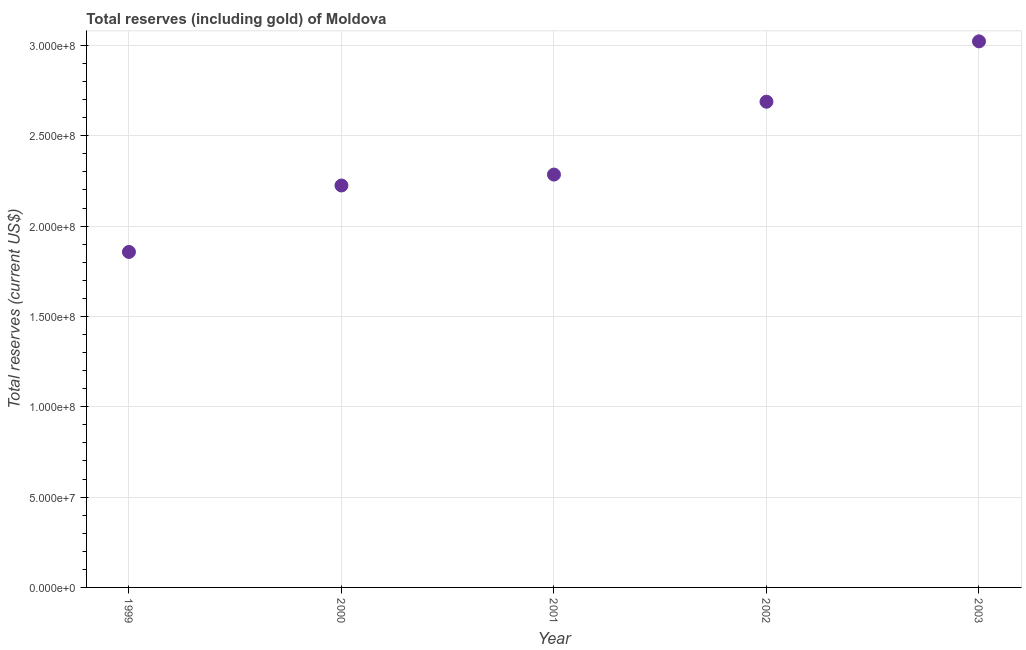What is the total reserves (including gold) in 2002?
Provide a short and direct response. 2.69e+08. Across all years, what is the maximum total reserves (including gold)?
Provide a short and direct response. 3.02e+08. Across all years, what is the minimum total reserves (including gold)?
Offer a very short reply. 1.86e+08. What is the sum of the total reserves (including gold)?
Your answer should be compact. 1.21e+09. What is the difference between the total reserves (including gold) in 2002 and 2003?
Give a very brief answer. -3.34e+07. What is the average total reserves (including gold) per year?
Keep it short and to the point. 2.42e+08. What is the median total reserves (including gold)?
Your answer should be compact. 2.29e+08. In how many years, is the total reserves (including gold) greater than 70000000 US$?
Offer a terse response. 5. What is the ratio of the total reserves (including gold) in 2000 to that in 2002?
Your response must be concise. 0.83. Is the total reserves (including gold) in 1999 less than that in 2001?
Offer a very short reply. Yes. What is the difference between the highest and the second highest total reserves (including gold)?
Provide a short and direct response. 3.34e+07. What is the difference between the highest and the lowest total reserves (including gold)?
Ensure brevity in your answer.  1.17e+08. In how many years, is the total reserves (including gold) greater than the average total reserves (including gold) taken over all years?
Provide a succinct answer. 2. How many dotlines are there?
Give a very brief answer. 1. Are the values on the major ticks of Y-axis written in scientific E-notation?
Offer a terse response. Yes. What is the title of the graph?
Offer a terse response. Total reserves (including gold) of Moldova. What is the label or title of the Y-axis?
Your answer should be very brief. Total reserves (current US$). What is the Total reserves (current US$) in 1999?
Offer a very short reply. 1.86e+08. What is the Total reserves (current US$) in 2000?
Make the answer very short. 2.22e+08. What is the Total reserves (current US$) in 2001?
Offer a very short reply. 2.29e+08. What is the Total reserves (current US$) in 2002?
Keep it short and to the point. 2.69e+08. What is the Total reserves (current US$) in 2003?
Provide a short and direct response. 3.02e+08. What is the difference between the Total reserves (current US$) in 1999 and 2000?
Your answer should be compact. -3.68e+07. What is the difference between the Total reserves (current US$) in 1999 and 2001?
Your answer should be compact. -4.28e+07. What is the difference between the Total reserves (current US$) in 1999 and 2002?
Provide a short and direct response. -8.32e+07. What is the difference between the Total reserves (current US$) in 1999 and 2003?
Your response must be concise. -1.17e+08. What is the difference between the Total reserves (current US$) in 2000 and 2001?
Give a very brief answer. -6.04e+06. What is the difference between the Total reserves (current US$) in 2000 and 2002?
Provide a short and direct response. -4.64e+07. What is the difference between the Total reserves (current US$) in 2000 and 2003?
Provide a short and direct response. -7.98e+07. What is the difference between the Total reserves (current US$) in 2001 and 2002?
Provide a short and direct response. -4.03e+07. What is the difference between the Total reserves (current US$) in 2001 and 2003?
Keep it short and to the point. -7.37e+07. What is the difference between the Total reserves (current US$) in 2002 and 2003?
Give a very brief answer. -3.34e+07. What is the ratio of the Total reserves (current US$) in 1999 to that in 2000?
Provide a short and direct response. 0.83. What is the ratio of the Total reserves (current US$) in 1999 to that in 2001?
Give a very brief answer. 0.81. What is the ratio of the Total reserves (current US$) in 1999 to that in 2002?
Provide a succinct answer. 0.69. What is the ratio of the Total reserves (current US$) in 1999 to that in 2003?
Give a very brief answer. 0.61. What is the ratio of the Total reserves (current US$) in 2000 to that in 2002?
Your response must be concise. 0.83. What is the ratio of the Total reserves (current US$) in 2000 to that in 2003?
Make the answer very short. 0.74. What is the ratio of the Total reserves (current US$) in 2001 to that in 2003?
Offer a very short reply. 0.76. What is the ratio of the Total reserves (current US$) in 2002 to that in 2003?
Provide a succinct answer. 0.89. 